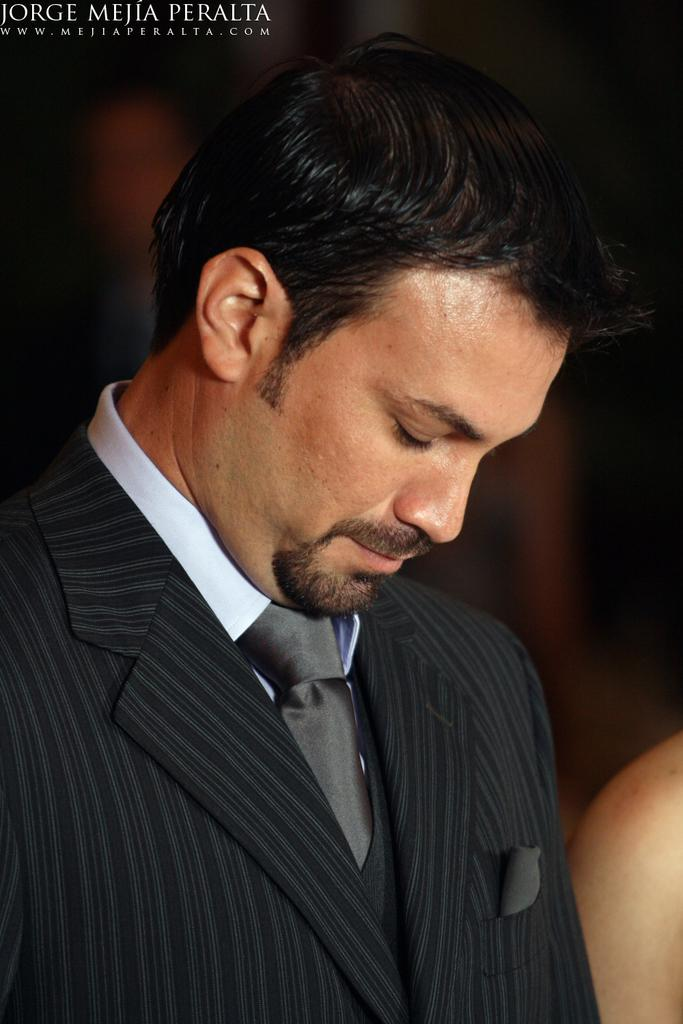What is the main subject in the front of the image? There is a person in the front of the image. How would you describe the background of the image? The background of the image is blurry. Is there any additional information or branding present in the image? Yes, there is a watermark at the top left side of the image. What type of noise can be heard coming from the person in the image? There is no sound or noise present in the image, as it is a still photograph. 